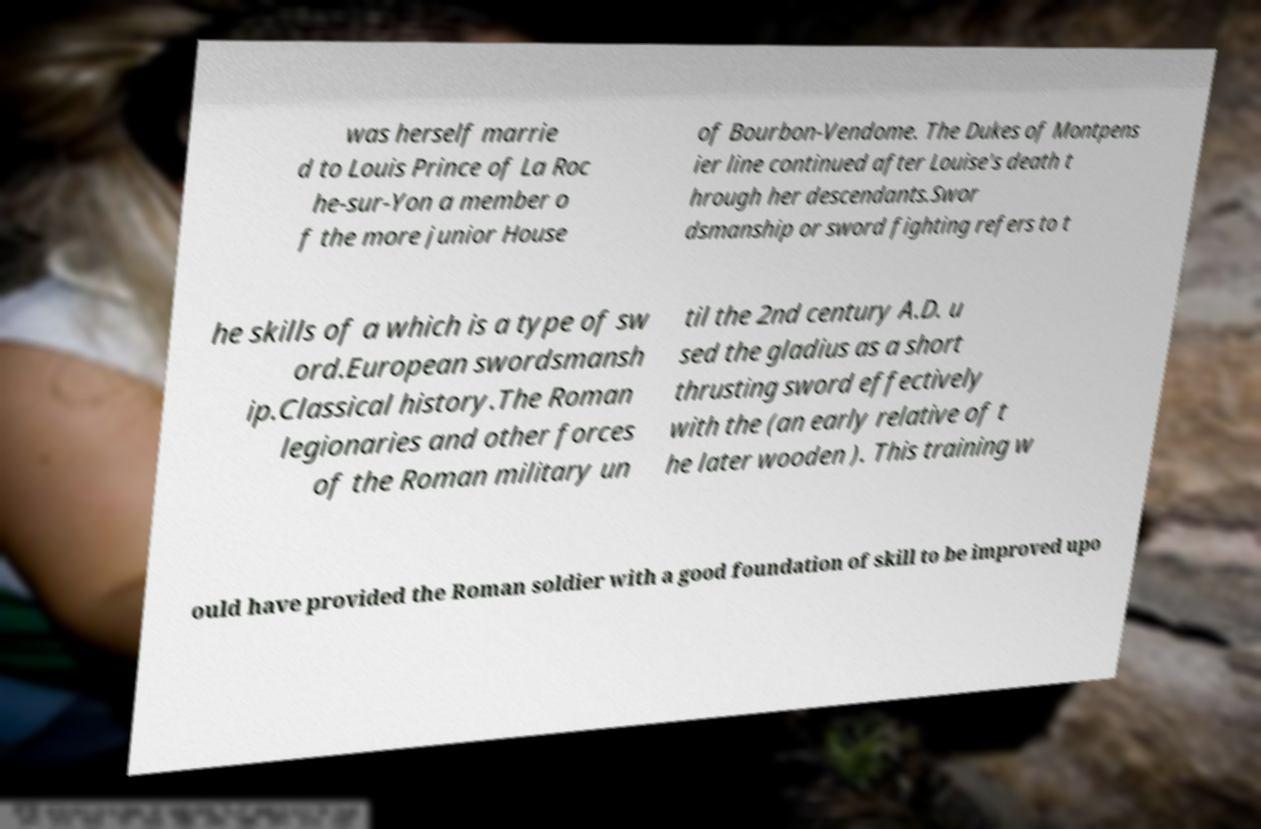Can you accurately transcribe the text from the provided image for me? was herself marrie d to Louis Prince of La Roc he-sur-Yon a member o f the more junior House of Bourbon-Vendome. The Dukes of Montpens ier line continued after Louise's death t hrough her descendants.Swor dsmanship or sword fighting refers to t he skills of a which is a type of sw ord.European swordsmansh ip.Classical history.The Roman legionaries and other forces of the Roman military un til the 2nd century A.D. u sed the gladius as a short thrusting sword effectively with the (an early relative of t he later wooden ). This training w ould have provided the Roman soldier with a good foundation of skill to be improved upo 